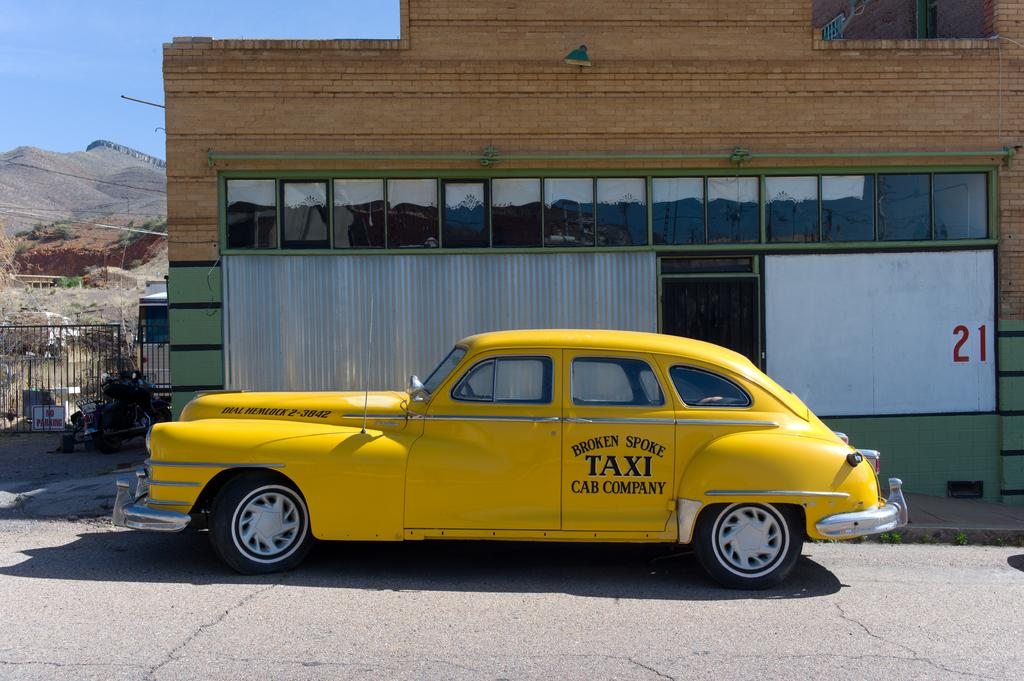Provide a one-sentence caption for the provided image. A yellow antique taxi is from the Broken Spike Cab Company. 